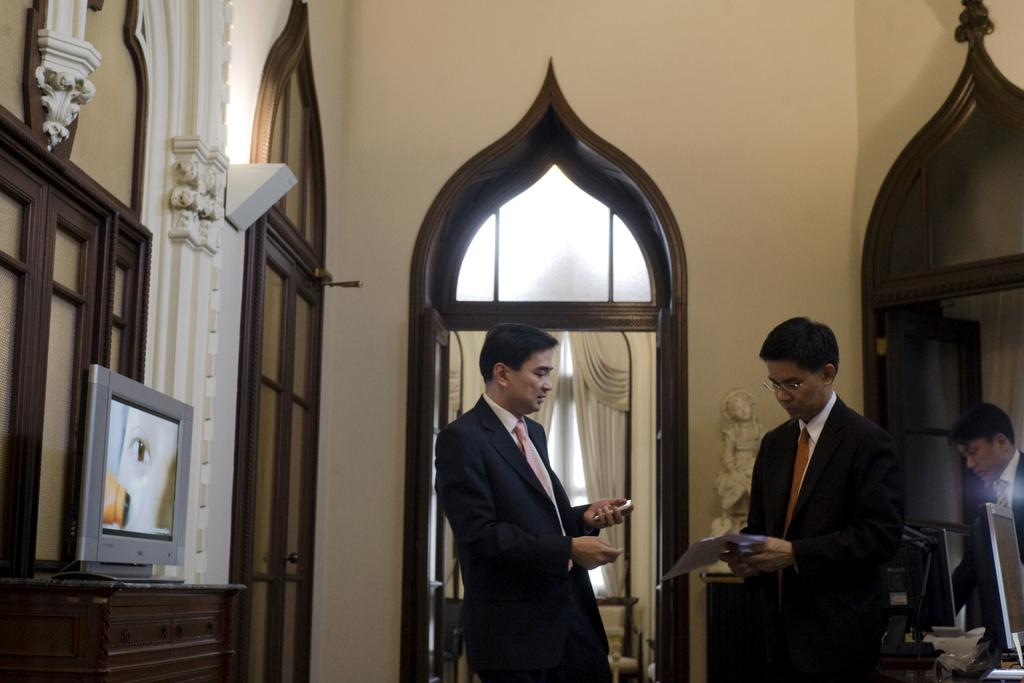How many people are in the image? There are three persons in the image. What are the persons doing in the image? The persons are standing. What can be seen in the background of the image? There is a wall and a door in the image. What are the persons holding in their hands? The persons are holding objects in their hands. What type of dolls are the persons biting in the image? There are no dolls or biting actions present in the image. 